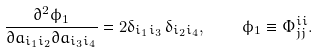<formula> <loc_0><loc_0><loc_500><loc_500>\frac { \partial ^ { 2 } \phi _ { 1 } } { \partial a _ { i _ { 1 } i _ { 2 } } \partial a _ { i _ { 3 } i _ { 4 } } } = 2 \delta _ { i _ { 1 } i _ { 3 } } \, \delta _ { i _ { 2 } i _ { 4 } } , \quad \phi _ { 1 } \equiv \Phi ^ { i i } _ { j j } .</formula> 